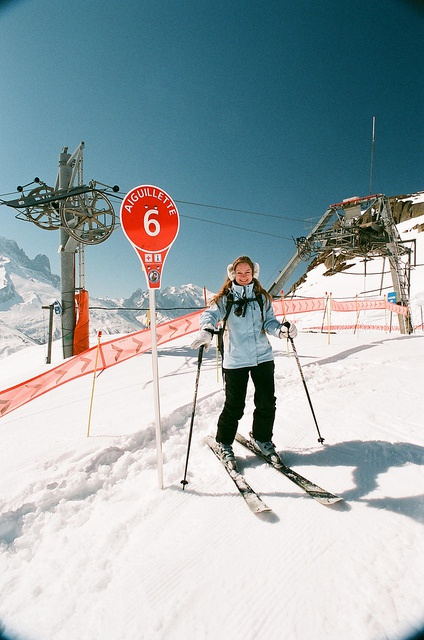Describe the objects in this image and their specific colors. I can see people in black, darkgray, lightgray, and gray tones and skis in black, lightgray, gray, and darkgray tones in this image. 